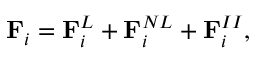Convert formula to latex. <formula><loc_0><loc_0><loc_500><loc_500>F _ { i } = F _ { i } ^ { L } + F _ { i } ^ { N L } + F _ { i } ^ { I I } ,</formula> 